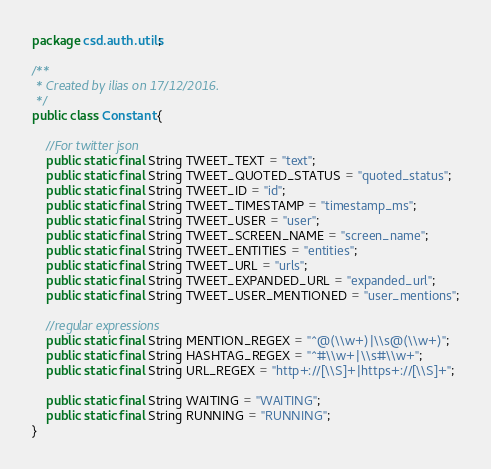<code> <loc_0><loc_0><loc_500><loc_500><_Java_>package csd.auth.utils;

/**
 * Created by ilias on 17/12/2016.
 */
public class Constant {

    //For twitter json
    public static final String TWEET_TEXT = "text";
    public static final String TWEET_QUOTED_STATUS = "quoted_status";
    public static final String TWEET_ID = "id";
    public static final String TWEET_TIMESTAMP = "timestamp_ms";
    public static final String TWEET_USER = "user";
    public static final String TWEET_SCREEN_NAME = "screen_name";
    public static final String TWEET_ENTITIES = "entities";
    public static final String TWEET_URL = "urls";
    public static final String TWEET_EXPANDED_URL = "expanded_url";
    public static final String TWEET_USER_MENTIONED = "user_mentions";

    //regular expressions
    public static final String MENTION_REGEX = "^@(\\w+)|\\s@(\\w+)";
    public static final String HASHTAG_REGEX = "^#\\w+|\\s#\\w+";
    public static final String URL_REGEX = "http+://[\\S]+|https+://[\\S]+";

    public static final String WAITING = "WAITING";
    public static final String RUNNING = "RUNNING";
}
</code> 